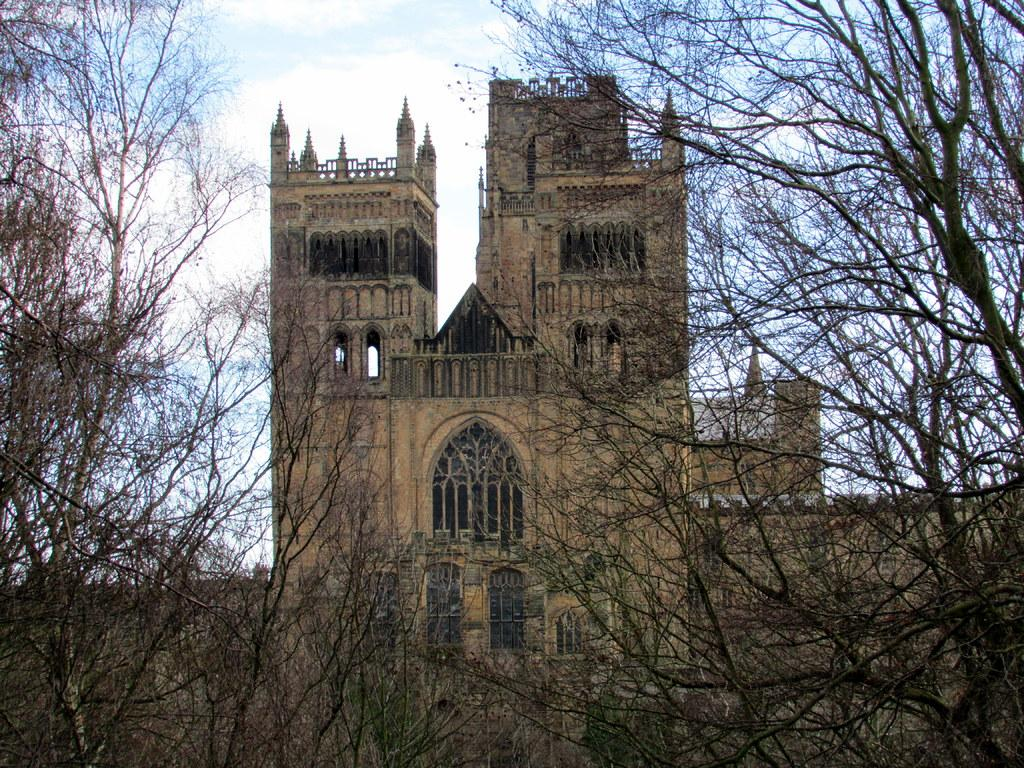What type of vegetation is visible in the front of the image? There are trees in the front of the image. What type of structure can be seen in the background of the image? There is a building in the background of the image. What can be seen in the sky in the background of the image? There are clouds in the background of the image. What part of the natural environment is visible in the background of the image? The sky is visible in the background of the image. What type of brass instrument is being played by the trees in the image? There is no brass instrument present in the image, as it features trees in the front and a building in the background. 